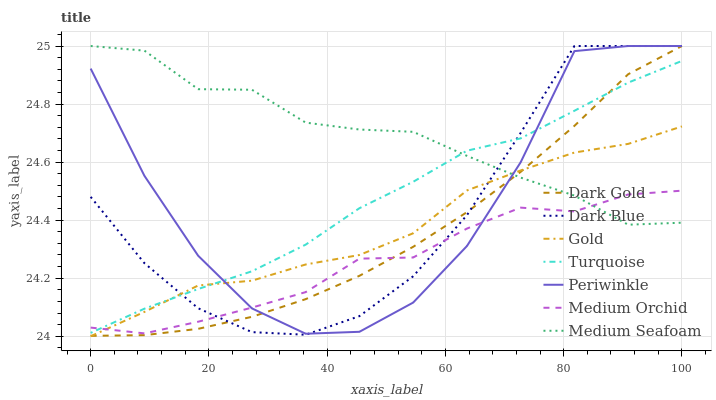Does Medium Orchid have the minimum area under the curve?
Answer yes or no. Yes. Does Medium Seafoam have the maximum area under the curve?
Answer yes or no. Yes. Does Gold have the minimum area under the curve?
Answer yes or no. No. Does Gold have the maximum area under the curve?
Answer yes or no. No. Is Dark Gold the smoothest?
Answer yes or no. Yes. Is Periwinkle the roughest?
Answer yes or no. Yes. Is Gold the smoothest?
Answer yes or no. No. Is Gold the roughest?
Answer yes or no. No. Does Gold have the lowest value?
Answer yes or no. Yes. Does Dark Gold have the lowest value?
Answer yes or no. No. Does Medium Seafoam have the highest value?
Answer yes or no. Yes. Does Gold have the highest value?
Answer yes or no. No. Does Medium Seafoam intersect Dark Gold?
Answer yes or no. Yes. Is Medium Seafoam less than Dark Gold?
Answer yes or no. No. Is Medium Seafoam greater than Dark Gold?
Answer yes or no. No. 